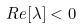Convert formula to latex. <formula><loc_0><loc_0><loc_500><loc_500>R e [ \lambda ] < 0</formula> 